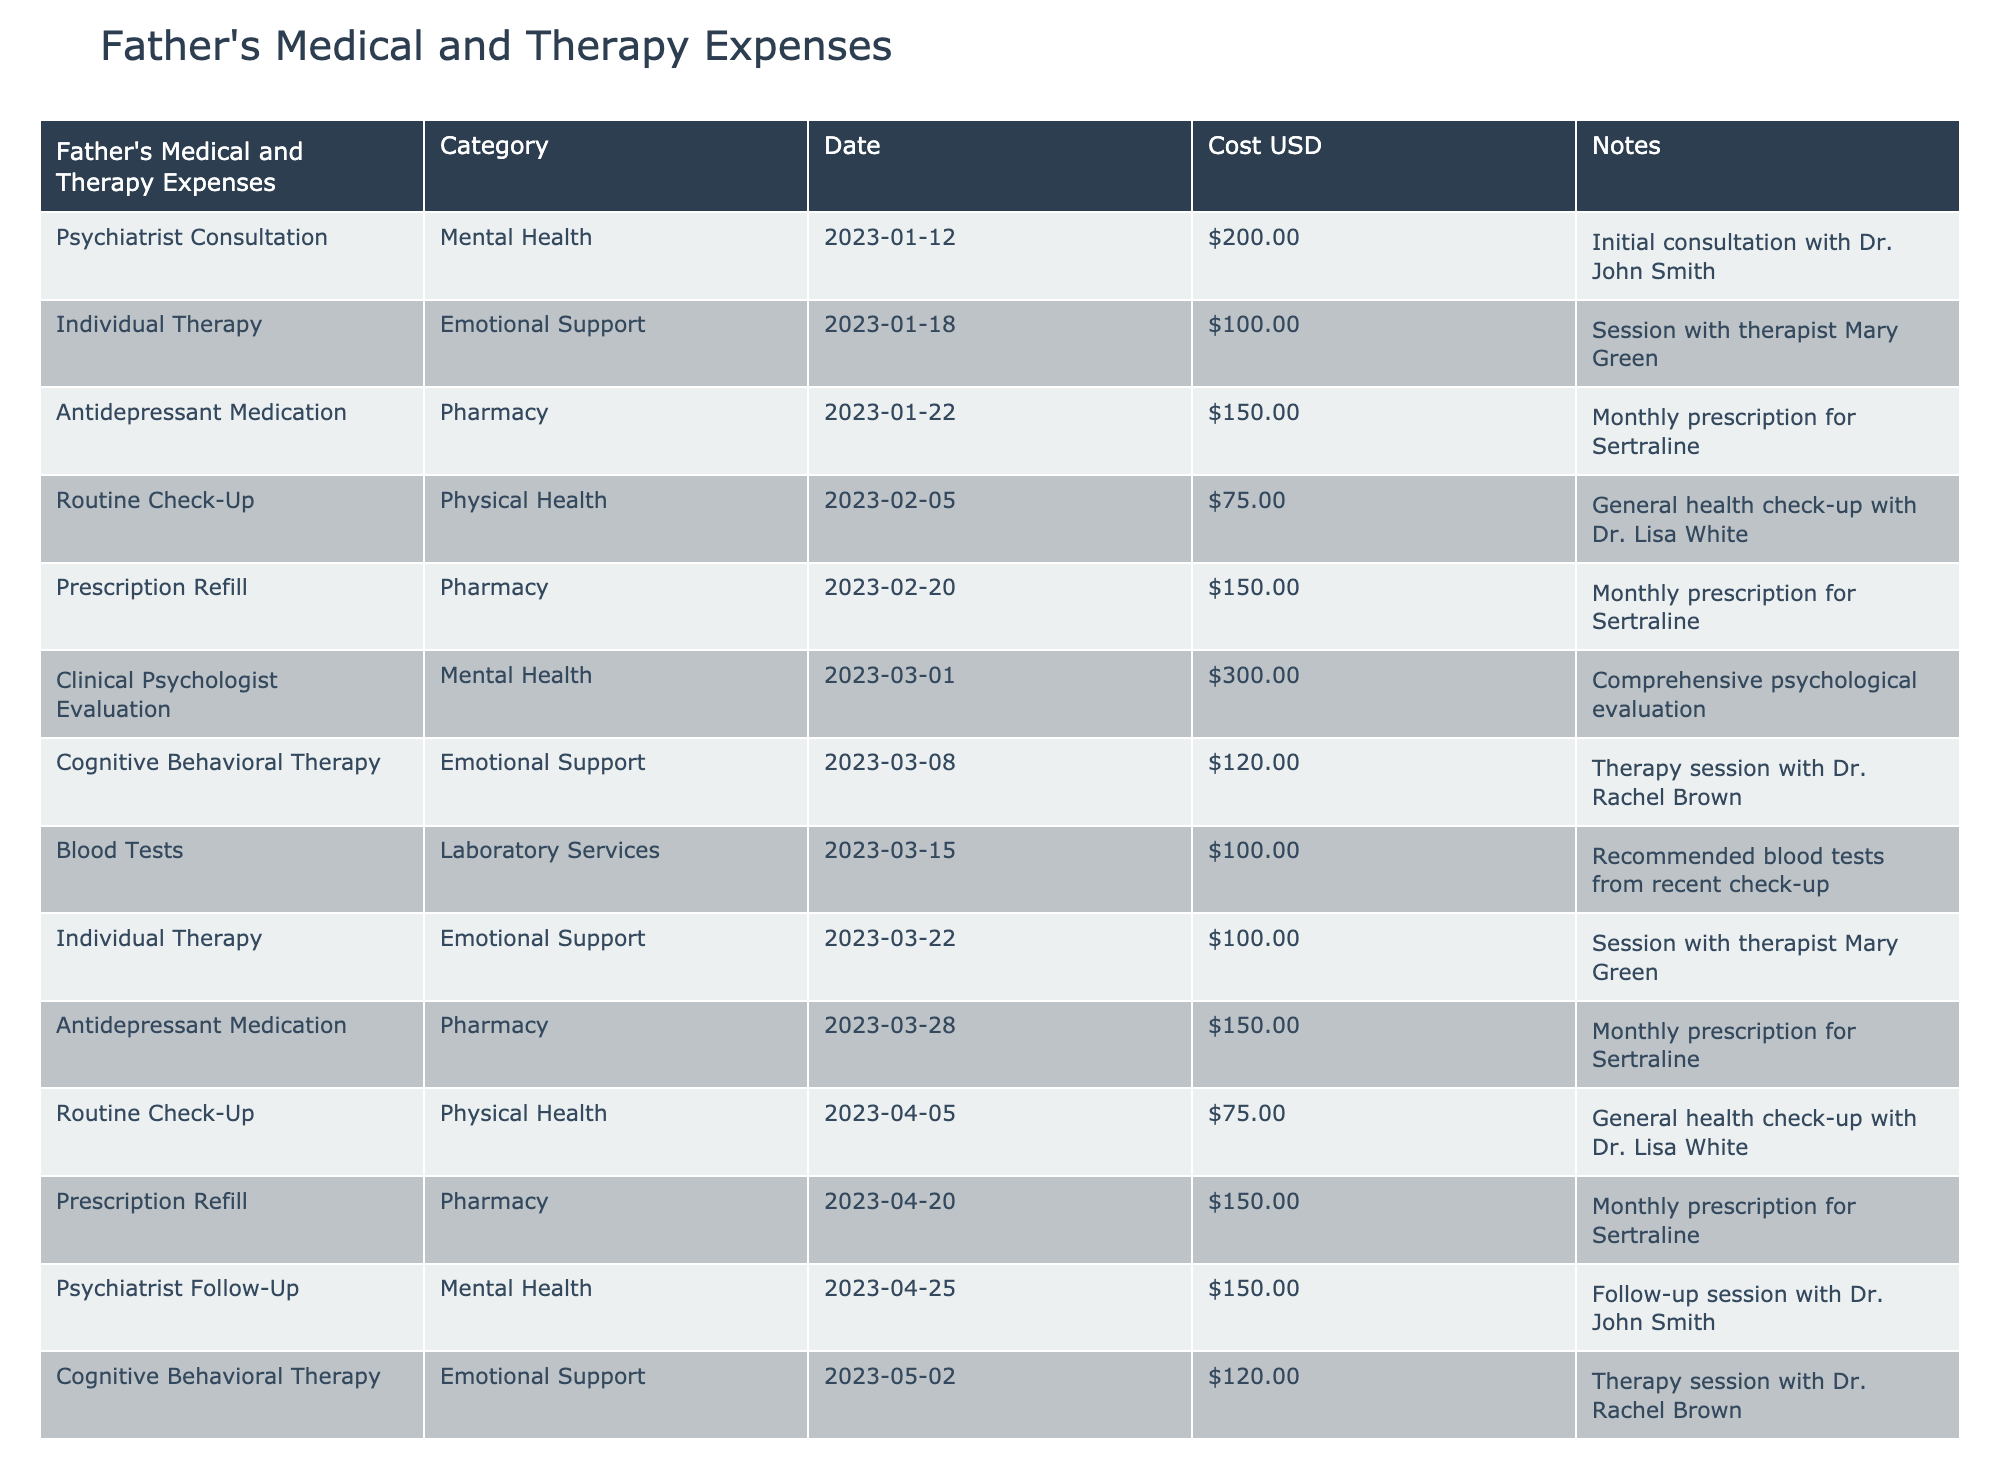What is the total amount spent on Emotional Support? To find the total spent on Emotional Support, we need to look at only the rows categorized under Emotional Support: Individual Therapy (100), Cognitive Behavioral Therapy (120), Individual Therapy (100), and Cognitive Behavioral Therapy (120). Adding these amounts gives us: 100 + 120 + 100 + 120 = 440.
Answer: 440 How many times did the father visit the psychiatrist in the table? The table lists two entries for the psychiatrist: one for an initial consultation and one for a follow-up session. Count these two entries to find the total.
Answer: 2 What is the average cost of the prescriptions for Antidepressant Medication? There are three entries for Antidepressant Medication, each costing 150. We calculate the total by multiplying the cost by the number of entries: 150 * 3 = 450. To get the average, divide this total by the number of prescriptions (3), which gives us 450 / 3 = 150.
Answer: 150 Was any check-up documented in February? We need to look for any rows with the category labeled as Physical Health and check their date. The table shows a Routine Check-Up on February 5, which means there is indeed a documented check-up in February.
Answer: Yes What is the difference between the total spending on Mental Health and Emotional Support? Start by calculating the total for each category. For Mental Health, the entries are 200 (Psychiatrist Consultation), 300 (Clinical Psychologist Evaluation), and 150 (Psychiatrist Follow-Up), leading to a total of: 200 + 300 + 150 = 650. For Emotional Support, previously calculated total is 440. The difference is then 650 - 440 = 210.
Answer: 210 How many different categories of expenses are listed in the table? The categories in the table include Mental Health, Emotional Support, Pharmacy, Physical Health, and Laboratory Services. Counting these unique categories gives us a total of five.
Answer: 5 What was the highest individual cost recorded in the table? Reviewing the costs listed, we find that Clinical Psychologist Evaluation at 300 is the highest individual cost present in the table when comparing all entries.
Answer: 300 How many therapy sessions were held in March? In March, looking through the table, we find two entries categorized under Emotional Support: Cognitive Behavioral Therapy (120) and Individual Therapy (100). Therefore, we have a total of three therapy sessions held in that month.
Answer: 3 